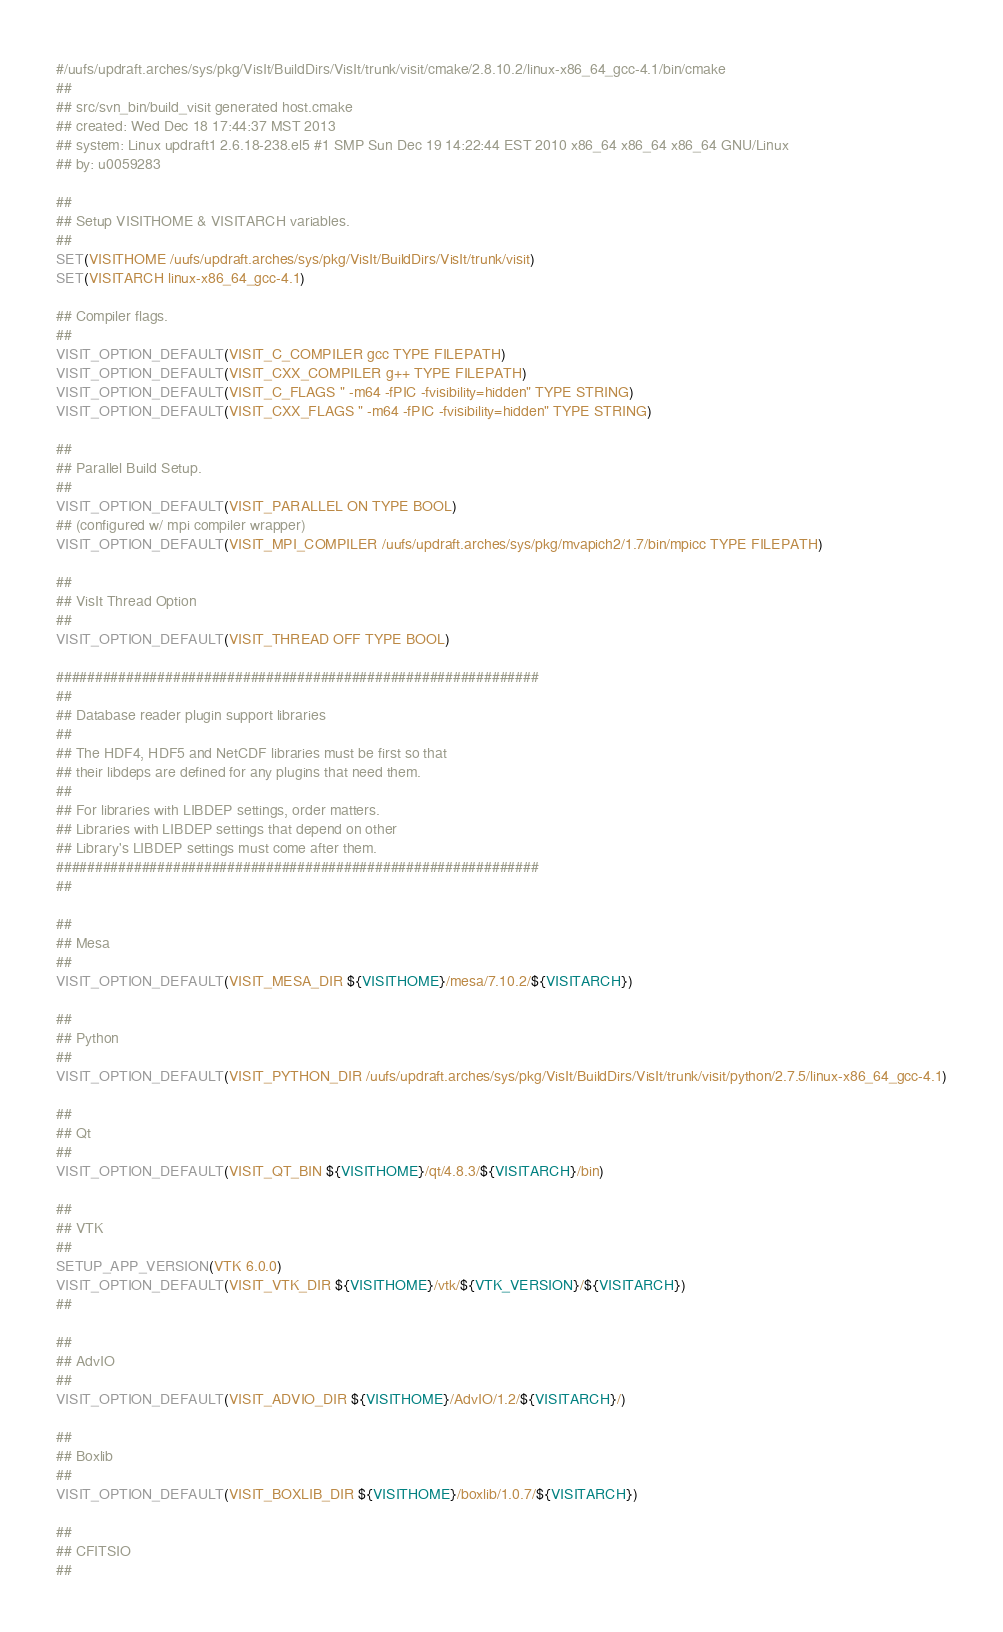<code> <loc_0><loc_0><loc_500><loc_500><_CMake_>#/uufs/updraft.arches/sys/pkg/VisIt/BuildDirs/VisIt/trunk/visit/cmake/2.8.10.2/linux-x86_64_gcc-4.1/bin/cmake
##
## src/svn_bin/build_visit generated host.cmake
## created: Wed Dec 18 17:44:37 MST 2013
## system: Linux updraft1 2.6.18-238.el5 #1 SMP Sun Dec 19 14:22:44 EST 2010 x86_64 x86_64 x86_64 GNU/Linux
## by: u0059283

##
## Setup VISITHOME & VISITARCH variables.
##
SET(VISITHOME /uufs/updraft.arches/sys/pkg/VisIt/BuildDirs/VisIt/trunk/visit)
SET(VISITARCH linux-x86_64_gcc-4.1)

## Compiler flags.
##
VISIT_OPTION_DEFAULT(VISIT_C_COMPILER gcc TYPE FILEPATH)
VISIT_OPTION_DEFAULT(VISIT_CXX_COMPILER g++ TYPE FILEPATH)
VISIT_OPTION_DEFAULT(VISIT_C_FLAGS " -m64 -fPIC -fvisibility=hidden" TYPE STRING)
VISIT_OPTION_DEFAULT(VISIT_CXX_FLAGS " -m64 -fPIC -fvisibility=hidden" TYPE STRING)

##
## Parallel Build Setup.
##
VISIT_OPTION_DEFAULT(VISIT_PARALLEL ON TYPE BOOL)
## (configured w/ mpi compiler wrapper)
VISIT_OPTION_DEFAULT(VISIT_MPI_COMPILER /uufs/updraft.arches/sys/pkg/mvapich2/1.7/bin/mpicc TYPE FILEPATH)

##
## VisIt Thread Option
##
VISIT_OPTION_DEFAULT(VISIT_THREAD OFF TYPE BOOL)

##############################################################
##
## Database reader plugin support libraries
##
## The HDF4, HDF5 and NetCDF libraries must be first so that
## their libdeps are defined for any plugins that need them.
##
## For libraries with LIBDEP settings, order matters.
## Libraries with LIBDEP settings that depend on other
## Library's LIBDEP settings must come after them.
##############################################################
##

##
## Mesa
##
VISIT_OPTION_DEFAULT(VISIT_MESA_DIR ${VISITHOME}/mesa/7.10.2/${VISITARCH})

##
## Python
##
VISIT_OPTION_DEFAULT(VISIT_PYTHON_DIR /uufs/updraft.arches/sys/pkg/VisIt/BuildDirs/VisIt/trunk/visit/python/2.7.5/linux-x86_64_gcc-4.1)

##
## Qt
##
VISIT_OPTION_DEFAULT(VISIT_QT_BIN ${VISITHOME}/qt/4.8.3/${VISITARCH}/bin)

##
## VTK
##
SETUP_APP_VERSION(VTK 6.0.0)
VISIT_OPTION_DEFAULT(VISIT_VTK_DIR ${VISITHOME}/vtk/${VTK_VERSION}/${VISITARCH})
##

##
## AdvIO
##
VISIT_OPTION_DEFAULT(VISIT_ADVIO_DIR ${VISITHOME}/AdvIO/1.2/${VISITARCH}/)

##
## Boxlib
##
VISIT_OPTION_DEFAULT(VISIT_BOXLIB_DIR ${VISITHOME}/boxlib/1.0.7/${VISITARCH})

##
## CFITSIO
##</code> 